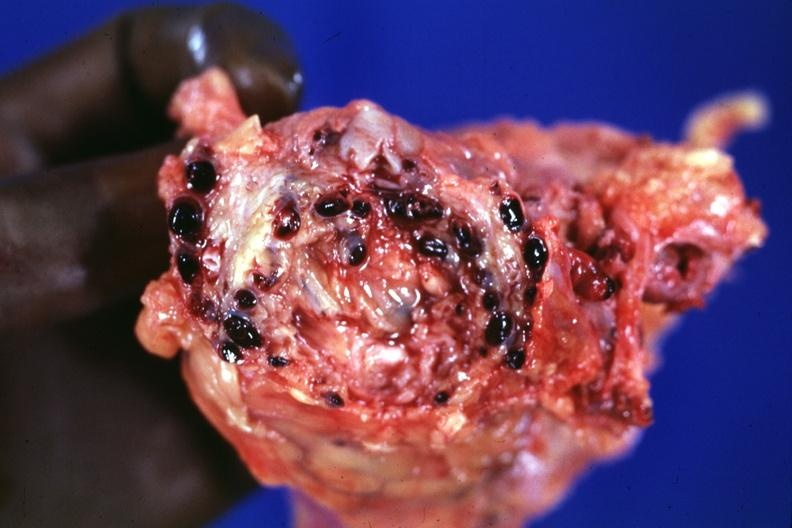s venous thrombosis present?
Answer the question using a single word or phrase. Yes 